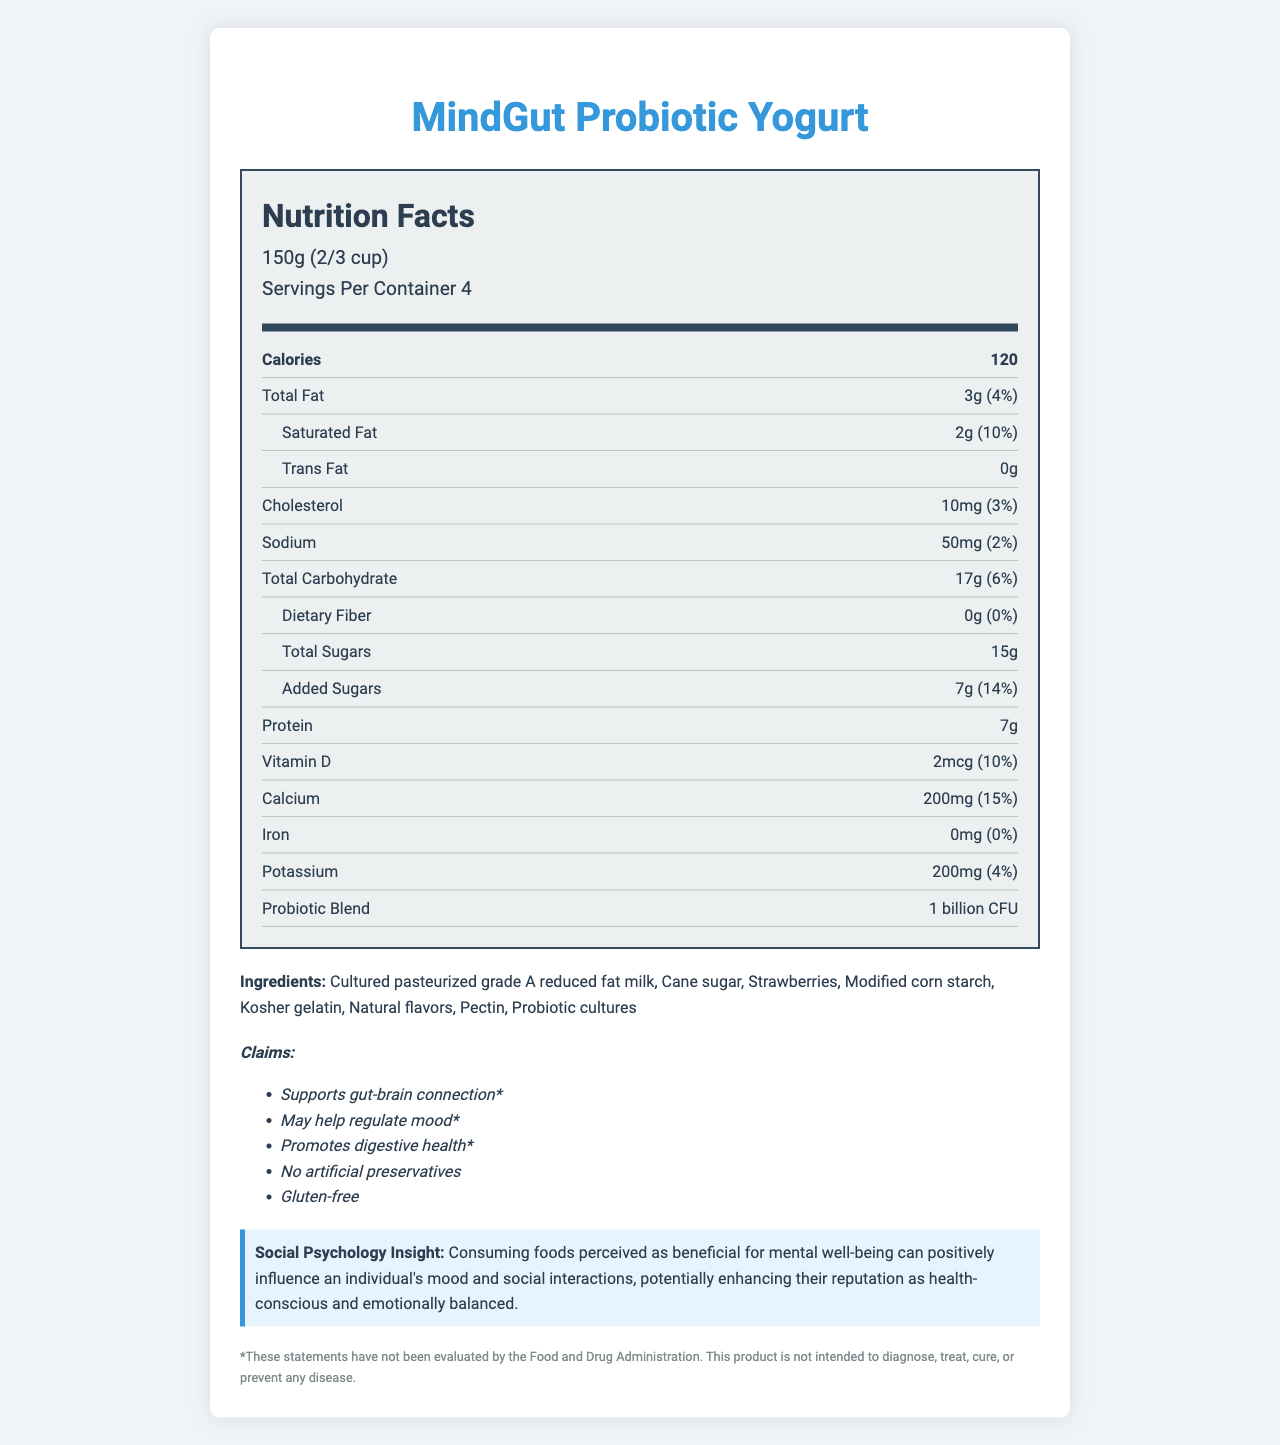What is the product name? The document title indicates that the product name is "MindGut Probiotic Yogurt".
Answer: MindGut Probiotic Yogurt How many servings per container are there? The document states that there are 4 servings per container.
Answer: 4 What is the total fat content per serving? The nutrition facts section mentions that the total fat content per serving is 3g.
Answer: 3g What is the daily value percentage of calcium in one serving? The nutrition facts indicate that the daily value percentage of calcium in one serving is 15%.
Answer: 15% Which probiotics are included in the probiotic blend? The document lists these three strains in the probiotic blend section.
Answer: Lactobacillus acidophilus, Bifidobacterium lactis, Lactobacillus rhamnosus What is the amount of protein per serving? The nutrition facts state that one serving contains 7g of protein.
Answer: 7g Which of the following claims are made by the product? A. No artificial preservatives B. Low sodium C. Vegan D. Gluten-free The claims section lists "No artificial preservatives" and "Gluten-free" but does not mention Low sodium or Vegan.
Answer: A. No artificial preservatives D. Gluten-free What is the main source of sugar in the ingredients list? A. Strawberries B. Cane sugar C. Corn starch D. Natural flavors The ingredient list includes "Cane sugar," which is a common source of added sugar.
Answer: B. Cane sugar Does the product contain any dietary fiber? The nutrition facts clearly state that it contains 0g of dietary fiber.
Answer: No Does the label indicate that the product is suitable for individuals avoiding gluten? The claims section lists "Gluten-free".
Answer: Yes Summarize the main idea of the document. The document summarizes the key nutritional components and health claims of MindGut Probiotic Yogurt, emphasizing its probiotic content and potential benefits for mood and gut health, alongside consumer perception insights.
Answer: The document provides detailed nutritional information about MindGut Probiotic Yogurt. It highlights the product's serving size, calorie content, macronutrients, micronutrients, and probiotic strains. The product claims to support the gut-brain connection, mood regulation, and digestive health. It also advocates for its health benefits and mentions that it is gluten-free and contains no artificial preservatives. A social psychology insight suggests that consuming this product can positively influence one's mood and social interactions, enhancing their reputation as health-conscious. What is the potential impact of consuming this product on social interactions and reputation according to the social psychology insight? The document states that consuming foods perceived as beneficial for mental well-being can positively influence mood and social interactions, enhancing reputation.
Answer: It can enhance reputation as health-conscious and emotionally balanced What is the amount of added sugars per serving, and what is its daily value percentage? The nutrition facts indicate that there are 7g of added sugars per serving, representing 14% of the daily value.
Answer: 7g, 14% What is the exact amount of sodium per serving? The nutrition facts list the sodium content as 50mg per serving.
Answer: 50mg Is there any trans fat in this product? The nutrition facts clearly state that the Trans Fat content is 0g.
Answer: No How much Vitamin D is in one serving of this yogurt? The document shows that one serving contains 2mcg of Vitamin D.
Answer: 2mcg What is the role claimed by the product related to mental well-being? The claims section mentions that the product supports the gut-brain connection and may help regulate mood.
Answer: Supports gut-brain connection, may help regulate mood What is the effect of the probiotic strains, according to the claims? The claims suggest that the probiotic strains promote digestive health.
Answer: Promotes digestive health What is the total calorie count for one container of yogurt? One serving is 120 calories, and there are 4 servings per container, so the total calorie count is 120 calories per serving * 4 servings = 480 calories.
Answer: 480 calories What does the document say about the product's ability to diagnose, treat, cure, or prevent any disease? The document includes a disclaimer stating that these statements have not been evaluated by the FDA and the product is not intended to diagnose, treat, cure, or prevent any disease.
Answer: Cannot be determined 